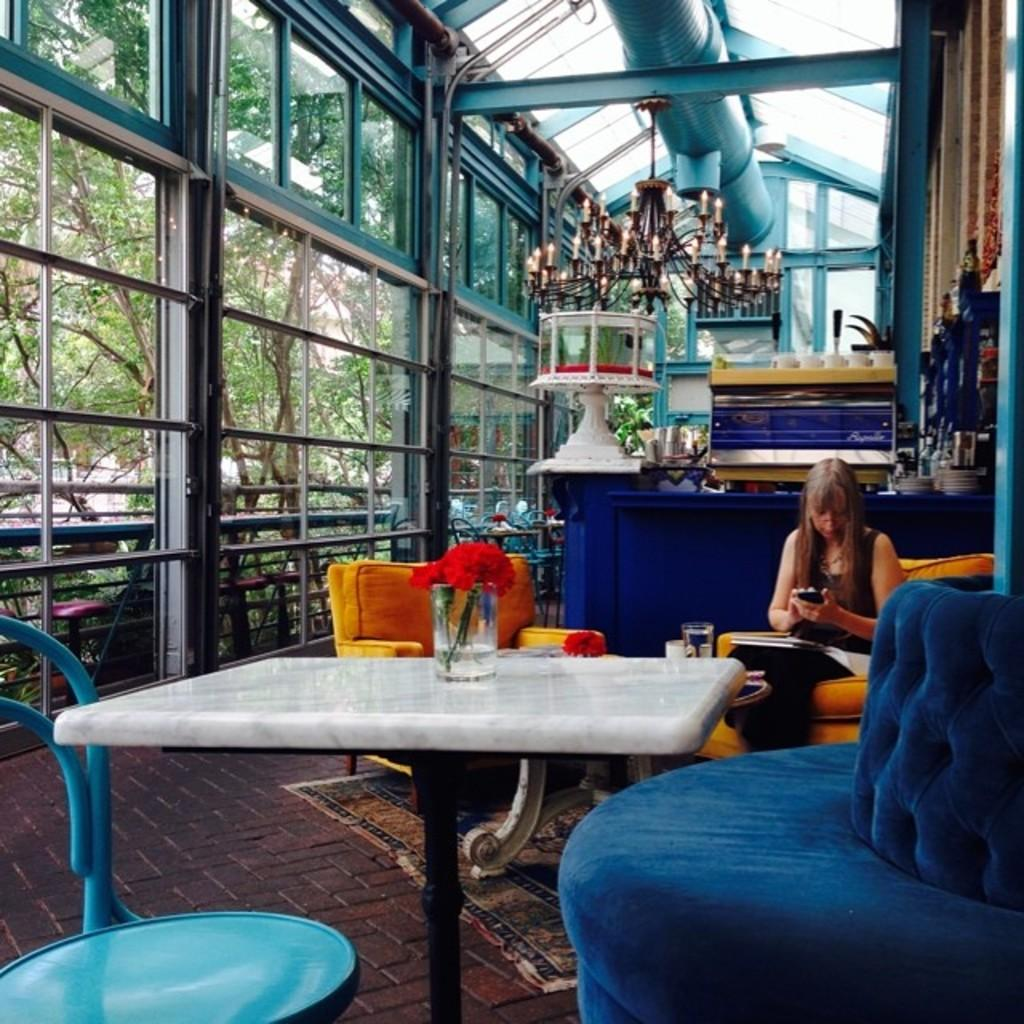Who is the main subject in the image? There is a woman in the image. What is the woman doing in the image? The woman is sitting on a chair. What object is in front of the woman? There is a table in front of the woman. What can be seen on the table? There is a glass on the table. What is inside the glass? Flowers are present in the glass. What type of boundary can be seen surrounding the woman in the image? There is no boundary surrounding the woman in the image. What wire is connected to the glass in the image? There is no wire connected to the glass in the image. 